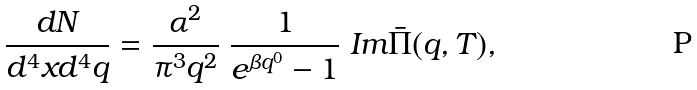Convert formula to latex. <formula><loc_0><loc_0><loc_500><loc_500>\frac { d N } { d ^ { 4 } x d ^ { 4 } q } = \frac { \alpha ^ { 2 } } { \pi ^ { 3 } q ^ { 2 } } \ \frac { 1 } { e ^ { \beta q ^ { 0 } } - 1 } \ I m \bar { \Pi } ( q , T ) ,</formula> 